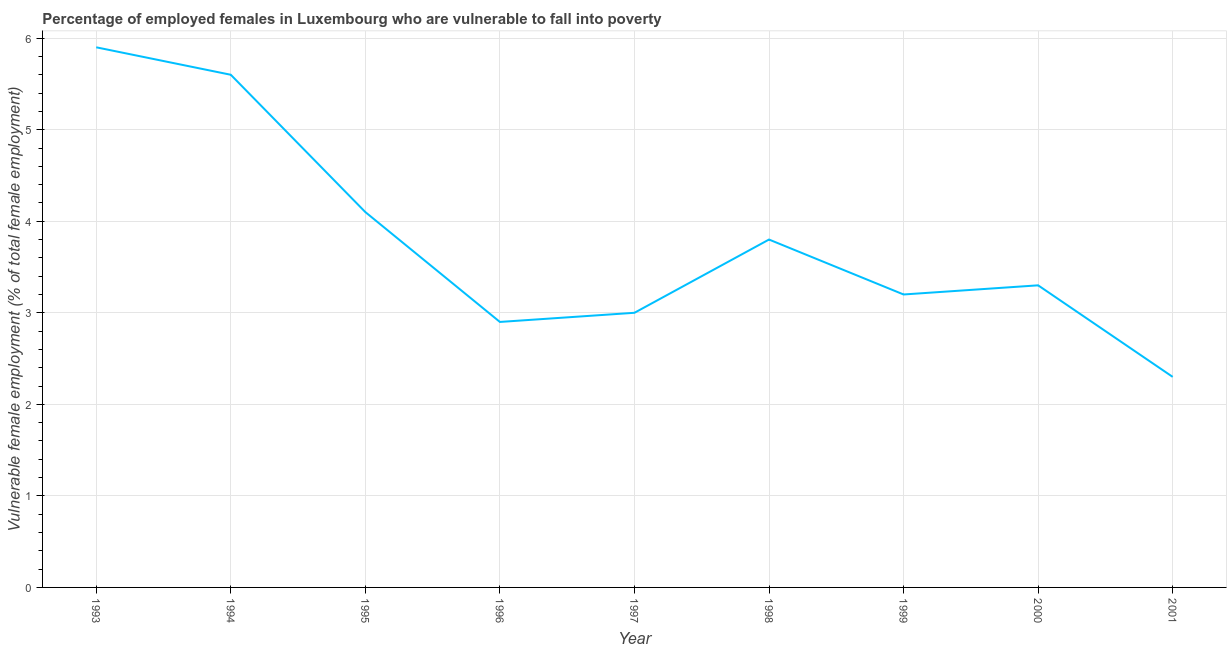What is the percentage of employed females who are vulnerable to fall into poverty in 1993?
Your answer should be compact. 5.9. Across all years, what is the maximum percentage of employed females who are vulnerable to fall into poverty?
Keep it short and to the point. 5.9. Across all years, what is the minimum percentage of employed females who are vulnerable to fall into poverty?
Your answer should be compact. 2.3. In which year was the percentage of employed females who are vulnerable to fall into poverty maximum?
Your answer should be compact. 1993. In which year was the percentage of employed females who are vulnerable to fall into poverty minimum?
Ensure brevity in your answer.  2001. What is the sum of the percentage of employed females who are vulnerable to fall into poverty?
Give a very brief answer. 34.1. What is the difference between the percentage of employed females who are vulnerable to fall into poverty in 1996 and 1997?
Give a very brief answer. -0.1. What is the average percentage of employed females who are vulnerable to fall into poverty per year?
Provide a short and direct response. 3.79. What is the median percentage of employed females who are vulnerable to fall into poverty?
Keep it short and to the point. 3.3. Do a majority of the years between 1999 and 1994 (inclusive) have percentage of employed females who are vulnerable to fall into poverty greater than 1 %?
Your answer should be very brief. Yes. What is the ratio of the percentage of employed females who are vulnerable to fall into poverty in 1994 to that in 1996?
Offer a terse response. 1.93. Is the percentage of employed females who are vulnerable to fall into poverty in 1995 less than that in 1998?
Make the answer very short. No. What is the difference between the highest and the second highest percentage of employed females who are vulnerable to fall into poverty?
Offer a terse response. 0.3. What is the difference between the highest and the lowest percentage of employed females who are vulnerable to fall into poverty?
Ensure brevity in your answer.  3.6. Does the percentage of employed females who are vulnerable to fall into poverty monotonically increase over the years?
Offer a terse response. No. How many lines are there?
Provide a succinct answer. 1. How many years are there in the graph?
Offer a terse response. 9. Does the graph contain any zero values?
Keep it short and to the point. No. What is the title of the graph?
Provide a succinct answer. Percentage of employed females in Luxembourg who are vulnerable to fall into poverty. What is the label or title of the Y-axis?
Offer a very short reply. Vulnerable female employment (% of total female employment). What is the Vulnerable female employment (% of total female employment) of 1993?
Your response must be concise. 5.9. What is the Vulnerable female employment (% of total female employment) of 1994?
Your answer should be compact. 5.6. What is the Vulnerable female employment (% of total female employment) of 1995?
Make the answer very short. 4.1. What is the Vulnerable female employment (% of total female employment) in 1996?
Provide a short and direct response. 2.9. What is the Vulnerable female employment (% of total female employment) in 1997?
Make the answer very short. 3. What is the Vulnerable female employment (% of total female employment) of 1998?
Provide a succinct answer. 3.8. What is the Vulnerable female employment (% of total female employment) of 1999?
Your answer should be very brief. 3.2. What is the Vulnerable female employment (% of total female employment) in 2000?
Offer a terse response. 3.3. What is the Vulnerable female employment (% of total female employment) in 2001?
Offer a very short reply. 2.3. What is the difference between the Vulnerable female employment (% of total female employment) in 1993 and 1994?
Offer a very short reply. 0.3. What is the difference between the Vulnerable female employment (% of total female employment) in 1993 and 1997?
Make the answer very short. 2.9. What is the difference between the Vulnerable female employment (% of total female employment) in 1993 and 1998?
Give a very brief answer. 2.1. What is the difference between the Vulnerable female employment (% of total female employment) in 1993 and 1999?
Offer a terse response. 2.7. What is the difference between the Vulnerable female employment (% of total female employment) in 1994 and 1996?
Make the answer very short. 2.7. What is the difference between the Vulnerable female employment (% of total female employment) in 1994 and 1998?
Keep it short and to the point. 1.8. What is the difference between the Vulnerable female employment (% of total female employment) in 1994 and 1999?
Provide a succinct answer. 2.4. What is the difference between the Vulnerable female employment (% of total female employment) in 1994 and 2001?
Your response must be concise. 3.3. What is the difference between the Vulnerable female employment (% of total female employment) in 1995 and 1996?
Keep it short and to the point. 1.2. What is the difference between the Vulnerable female employment (% of total female employment) in 1995 and 1997?
Keep it short and to the point. 1.1. What is the difference between the Vulnerable female employment (% of total female employment) in 1995 and 1998?
Provide a succinct answer. 0.3. What is the difference between the Vulnerable female employment (% of total female employment) in 1996 and 1997?
Keep it short and to the point. -0.1. What is the difference between the Vulnerable female employment (% of total female employment) in 1996 and 2000?
Ensure brevity in your answer.  -0.4. What is the difference between the Vulnerable female employment (% of total female employment) in 1996 and 2001?
Give a very brief answer. 0.6. What is the difference between the Vulnerable female employment (% of total female employment) in 1997 and 2000?
Keep it short and to the point. -0.3. What is the difference between the Vulnerable female employment (% of total female employment) in 1998 and 2001?
Your answer should be compact. 1.5. What is the difference between the Vulnerable female employment (% of total female employment) in 1999 and 2000?
Your answer should be compact. -0.1. What is the difference between the Vulnerable female employment (% of total female employment) in 2000 and 2001?
Give a very brief answer. 1. What is the ratio of the Vulnerable female employment (% of total female employment) in 1993 to that in 1994?
Offer a terse response. 1.05. What is the ratio of the Vulnerable female employment (% of total female employment) in 1993 to that in 1995?
Your response must be concise. 1.44. What is the ratio of the Vulnerable female employment (% of total female employment) in 1993 to that in 1996?
Your answer should be very brief. 2.03. What is the ratio of the Vulnerable female employment (% of total female employment) in 1993 to that in 1997?
Offer a very short reply. 1.97. What is the ratio of the Vulnerable female employment (% of total female employment) in 1993 to that in 1998?
Your response must be concise. 1.55. What is the ratio of the Vulnerable female employment (% of total female employment) in 1993 to that in 1999?
Your answer should be compact. 1.84. What is the ratio of the Vulnerable female employment (% of total female employment) in 1993 to that in 2000?
Provide a short and direct response. 1.79. What is the ratio of the Vulnerable female employment (% of total female employment) in 1993 to that in 2001?
Offer a terse response. 2.56. What is the ratio of the Vulnerable female employment (% of total female employment) in 1994 to that in 1995?
Give a very brief answer. 1.37. What is the ratio of the Vulnerable female employment (% of total female employment) in 1994 to that in 1996?
Offer a very short reply. 1.93. What is the ratio of the Vulnerable female employment (% of total female employment) in 1994 to that in 1997?
Your answer should be compact. 1.87. What is the ratio of the Vulnerable female employment (% of total female employment) in 1994 to that in 1998?
Give a very brief answer. 1.47. What is the ratio of the Vulnerable female employment (% of total female employment) in 1994 to that in 1999?
Provide a succinct answer. 1.75. What is the ratio of the Vulnerable female employment (% of total female employment) in 1994 to that in 2000?
Keep it short and to the point. 1.7. What is the ratio of the Vulnerable female employment (% of total female employment) in 1994 to that in 2001?
Your answer should be very brief. 2.44. What is the ratio of the Vulnerable female employment (% of total female employment) in 1995 to that in 1996?
Offer a very short reply. 1.41. What is the ratio of the Vulnerable female employment (% of total female employment) in 1995 to that in 1997?
Make the answer very short. 1.37. What is the ratio of the Vulnerable female employment (% of total female employment) in 1995 to that in 1998?
Give a very brief answer. 1.08. What is the ratio of the Vulnerable female employment (% of total female employment) in 1995 to that in 1999?
Your response must be concise. 1.28. What is the ratio of the Vulnerable female employment (% of total female employment) in 1995 to that in 2000?
Offer a very short reply. 1.24. What is the ratio of the Vulnerable female employment (% of total female employment) in 1995 to that in 2001?
Provide a succinct answer. 1.78. What is the ratio of the Vulnerable female employment (% of total female employment) in 1996 to that in 1997?
Offer a very short reply. 0.97. What is the ratio of the Vulnerable female employment (% of total female employment) in 1996 to that in 1998?
Offer a terse response. 0.76. What is the ratio of the Vulnerable female employment (% of total female employment) in 1996 to that in 1999?
Provide a short and direct response. 0.91. What is the ratio of the Vulnerable female employment (% of total female employment) in 1996 to that in 2000?
Your answer should be compact. 0.88. What is the ratio of the Vulnerable female employment (% of total female employment) in 1996 to that in 2001?
Provide a succinct answer. 1.26. What is the ratio of the Vulnerable female employment (% of total female employment) in 1997 to that in 1998?
Your answer should be compact. 0.79. What is the ratio of the Vulnerable female employment (% of total female employment) in 1997 to that in 1999?
Offer a very short reply. 0.94. What is the ratio of the Vulnerable female employment (% of total female employment) in 1997 to that in 2000?
Give a very brief answer. 0.91. What is the ratio of the Vulnerable female employment (% of total female employment) in 1997 to that in 2001?
Ensure brevity in your answer.  1.3. What is the ratio of the Vulnerable female employment (% of total female employment) in 1998 to that in 1999?
Ensure brevity in your answer.  1.19. What is the ratio of the Vulnerable female employment (% of total female employment) in 1998 to that in 2000?
Your answer should be very brief. 1.15. What is the ratio of the Vulnerable female employment (% of total female employment) in 1998 to that in 2001?
Offer a very short reply. 1.65. What is the ratio of the Vulnerable female employment (% of total female employment) in 1999 to that in 2001?
Your answer should be compact. 1.39. What is the ratio of the Vulnerable female employment (% of total female employment) in 2000 to that in 2001?
Keep it short and to the point. 1.44. 